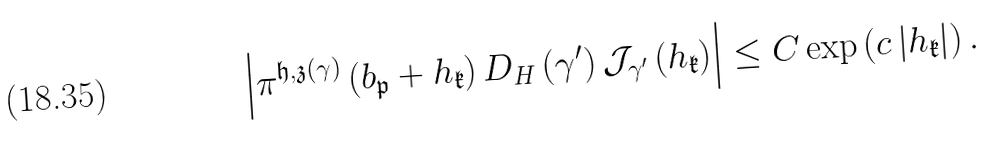Convert formula to latex. <formula><loc_0><loc_0><loc_500><loc_500>\left | \pi ^ { \mathfrak h , \mathfrak z \left ( \gamma \right ) } \left ( b _ { \mathfrak p } + h _ { \mathfrak k } \right ) D _ { H } \left ( \gamma ^ { \prime } \right ) \mathcal { J } _ { \gamma ^ { \prime } } \left ( h _ { \mathfrak k } \right ) \right | \leq C \exp \left ( c \left | h _ { \mathfrak k } \right | \right ) .</formula> 